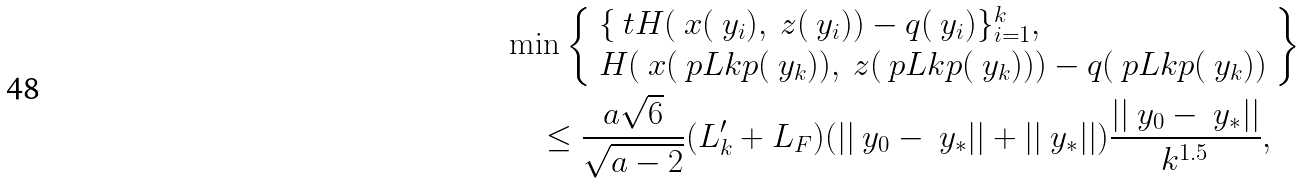<formula> <loc_0><loc_0><loc_500><loc_500>& \min \left \{ \begin{array} { l } \{ \ t H ( \ x ( \ y _ { i } ) , \ z ( \ y _ { i } ) ) - q ( \ y _ { i } ) \} _ { i = 1 } ^ { k } , \\ H ( \ x ( \ p L k p ( \ y _ { k } ) ) , \ z ( \ p L k p ( \ y _ { k } ) ) ) - q ( \ p L k p ( \ y _ { k } ) ) \end{array} \right \} \\ & \quad \leq \frac { a \sqrt { 6 } } { \sqrt { a - 2 } } ( L _ { k } ^ { \prime } + L _ { F } ) ( | | \ y _ { 0 } - \ y _ { * } | | + | | \ y _ { * } | | ) \frac { | | \ y _ { 0 } - \ y _ { * } | | } { k ^ { 1 . 5 } } ,</formula> 